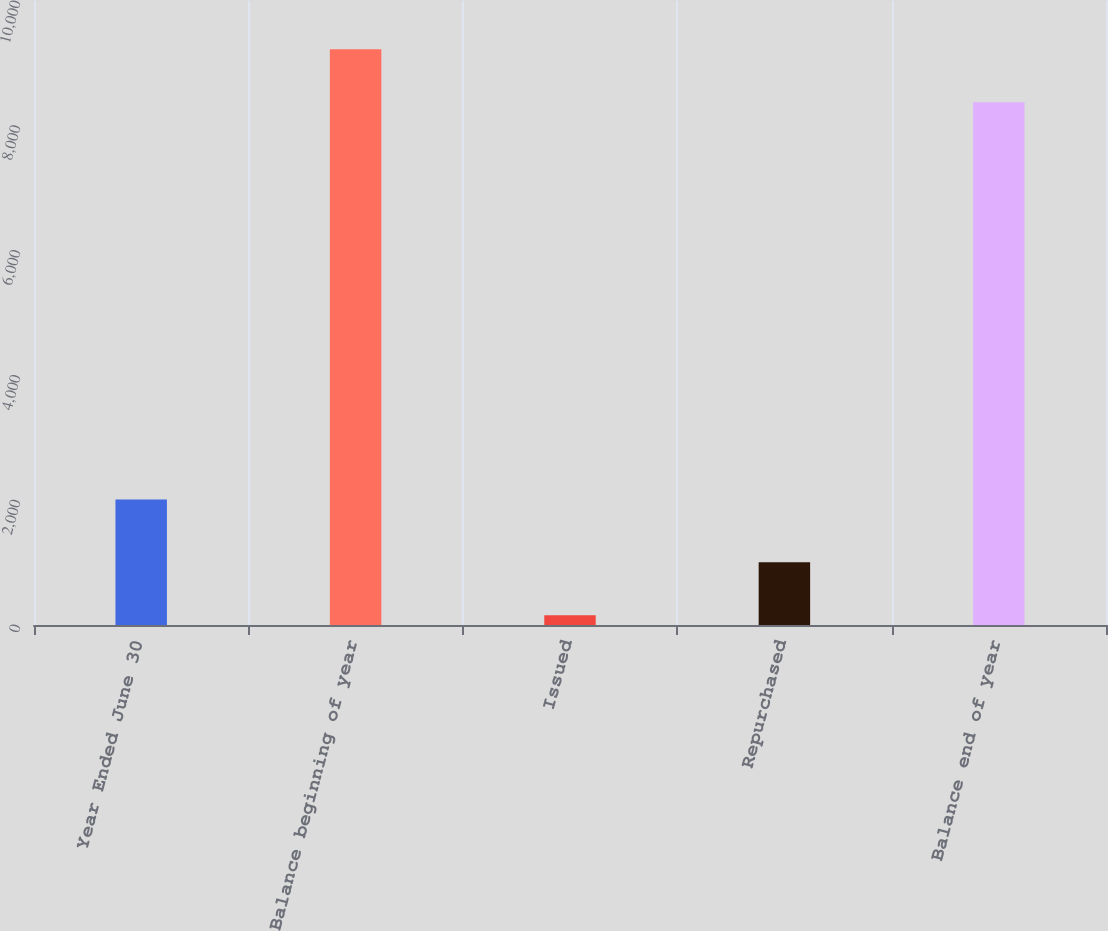<chart> <loc_0><loc_0><loc_500><loc_500><bar_chart><fcel>Year Ended June 30<fcel>Balance beginning of year<fcel>Issued<fcel>Repurchased<fcel>Balance end of year<nl><fcel>2011<fcel>9227.3<fcel>155<fcel>1006.3<fcel>8376<nl></chart> 